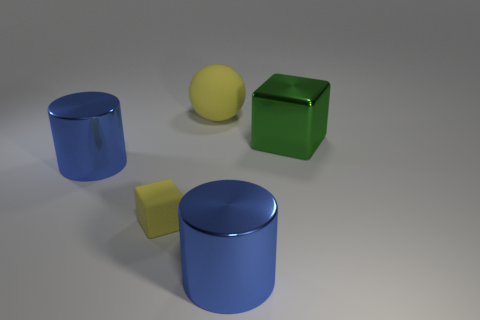Add 2 tiny rubber objects. How many objects exist? 7 Subtract all yellow blocks. How many blocks are left? 1 Subtract all spheres. How many objects are left? 4 Subtract 0 purple cylinders. How many objects are left? 5 Subtract 2 blocks. How many blocks are left? 0 Subtract all gray balls. Subtract all yellow cylinders. How many balls are left? 1 Subtract all yellow balls. How many green blocks are left? 1 Subtract all small cyan cubes. Subtract all big yellow matte spheres. How many objects are left? 4 Add 2 large cylinders. How many large cylinders are left? 4 Add 2 small red spheres. How many small red spheres exist? 2 